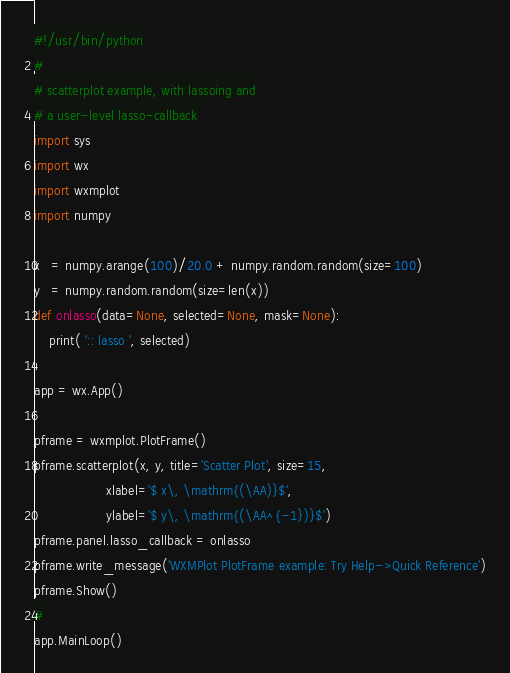Convert code to text. <code><loc_0><loc_0><loc_500><loc_500><_Python_>#!/usr/bin/python
#
# scatterplot example, with lassoing and
# a user-level lasso-callback
import sys
import wx
import wxmplot
import numpy

x   = numpy.arange(100)/20.0 + numpy.random.random(size=100)
y   = numpy.random.random(size=len(x))
def onlasso(data=None, selected=None, mask=None):
    print( ':: lasso ', selected)

app = wx.App()

pframe = wxmplot.PlotFrame()
pframe.scatterplot(x, y, title='Scatter Plot', size=15,
                   xlabel='$ x\, \mathrm{(\AA)}$',
                   ylabel='$ y\, \mathrm{(\AA^{-1})}$')
pframe.panel.lasso_callback = onlasso
pframe.write_message('WXMPlot PlotFrame example: Try Help->Quick Reference')
pframe.Show()
#
app.MainLoop()
</code> 